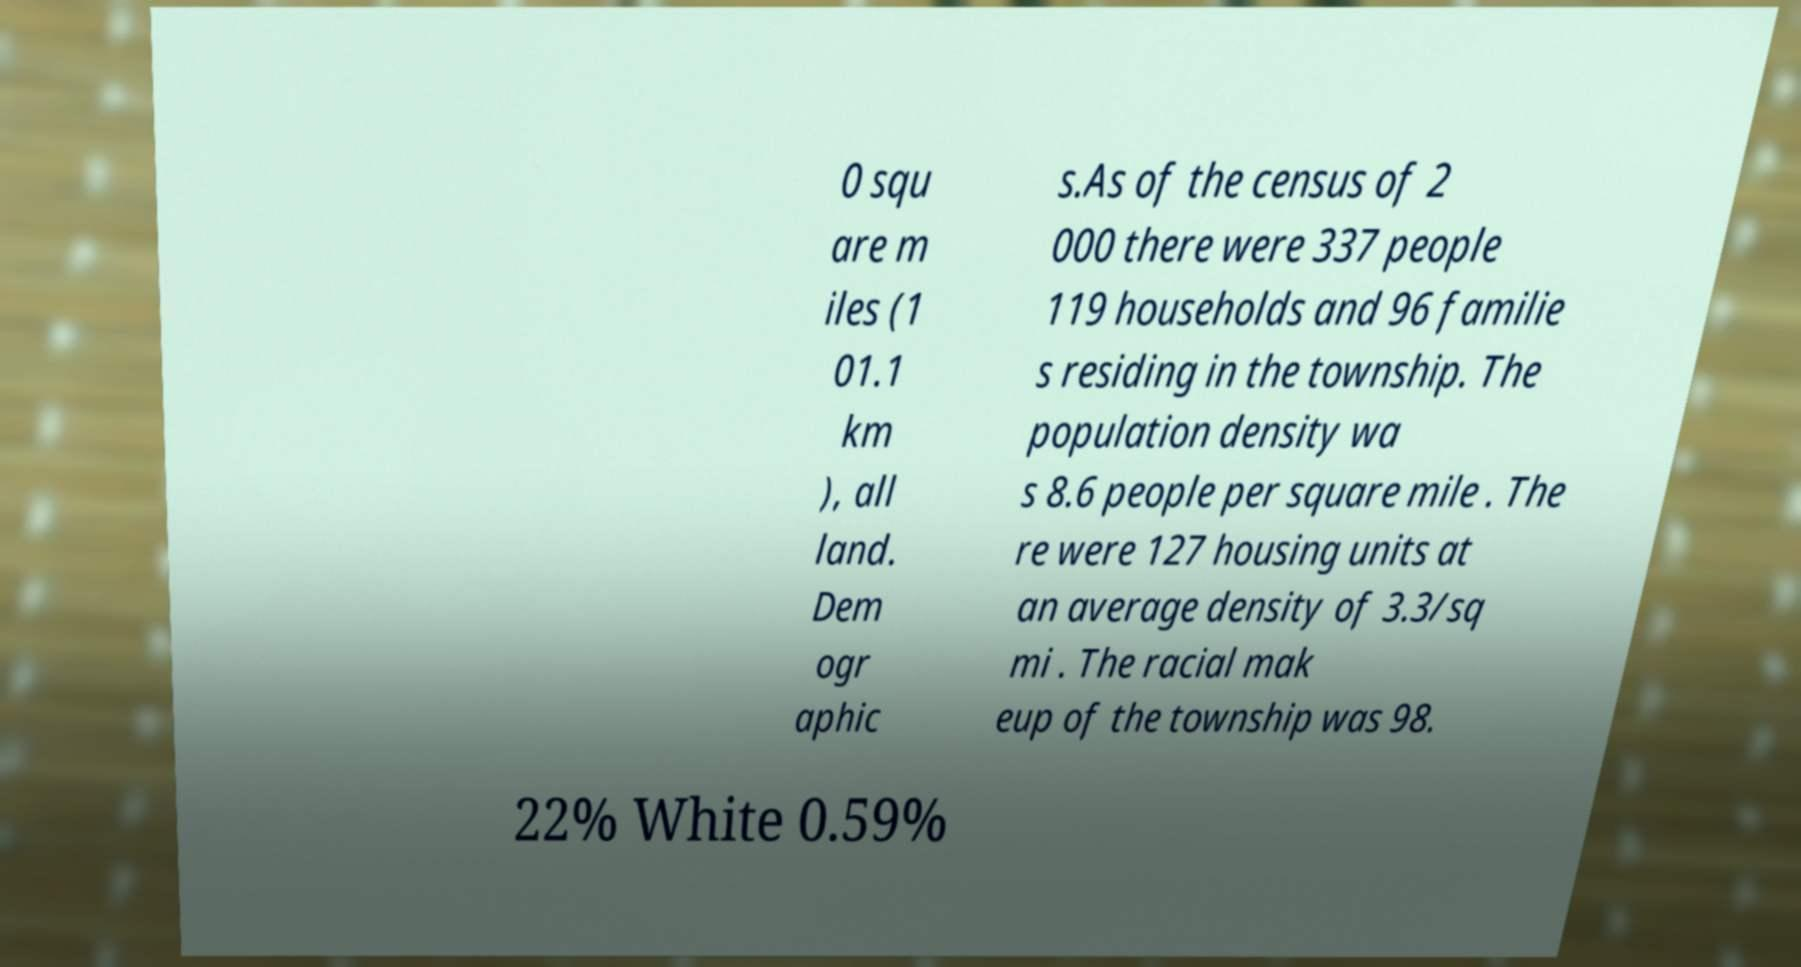There's text embedded in this image that I need extracted. Can you transcribe it verbatim? 0 squ are m iles (1 01.1 km ), all land. Dem ogr aphic s.As of the census of 2 000 there were 337 people 119 households and 96 familie s residing in the township. The population density wa s 8.6 people per square mile . The re were 127 housing units at an average density of 3.3/sq mi . The racial mak eup of the township was 98. 22% White 0.59% 